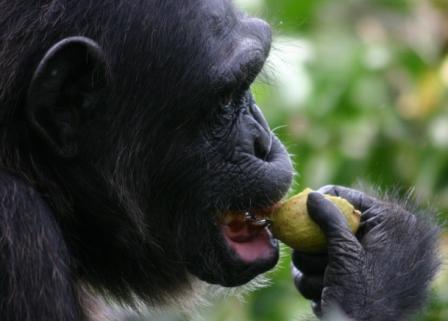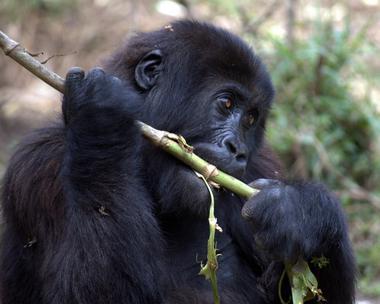The first image is the image on the left, the second image is the image on the right. Analyze the images presented: Is the assertion "One of the photos contains more than one animal." valid? Answer yes or no. No. The first image is the image on the left, the second image is the image on the right. Assess this claim about the two images: "The gorilla in the right image is chewing on a fibrous stalk.". Correct or not? Answer yes or no. Yes. 